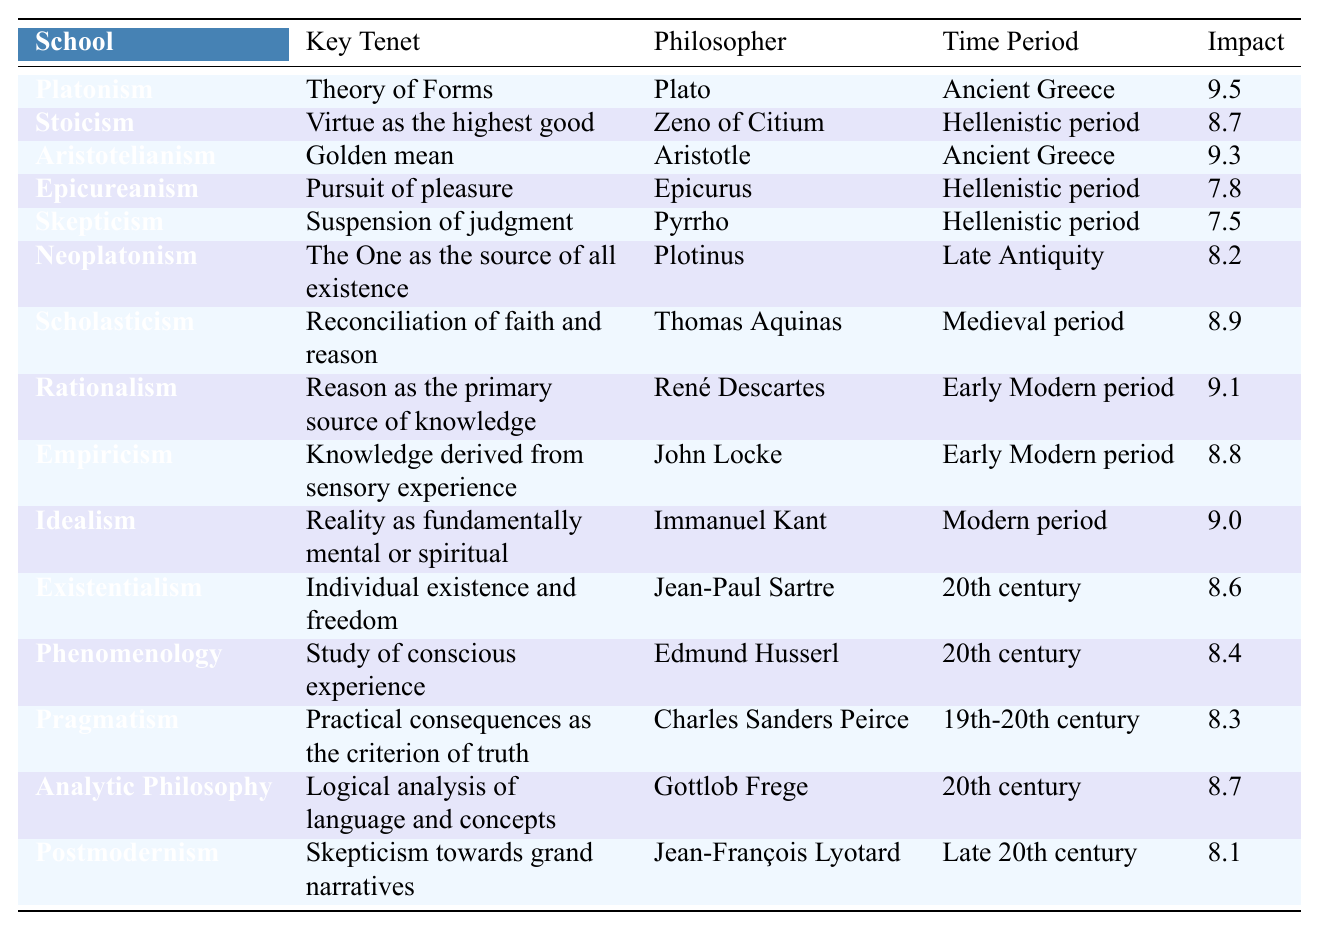What is the key tenet of Stoicism? The table provides a clear entry for Stoicism, showing that its key tenet is "Virtue as the highest good."
Answer: Virtue as the highest good Which philosopher is associated with Aristotelianism? From the table, we observe that Aristotelianism is linked to Aristotle.
Answer: Aristotle How many philosophical schools are associated with the Hellenistic period? The table includes three schools from the Hellenistic period: Stoicism, Epicureanism, and Skepticism, making a total of three.
Answer: 3 What is the impact score of Neoplatonism? Neoplatonism has an impact score of 8.2 as indicated in the table.
Answer: 8.2 Is it true that Rationalism has a higher impact score than Empiricism? The table shows Rationalism with an impact score of 9.1 and Empiricism with 8.8; thus, it is true that Rationalism has a higher score.
Answer: Yes What is the average impact score of the schools from the Ancient Greece? The impact scores for the Ancient Greece schools (Platonism: 9.5, Aristotelianism: 9.3) sum to 18.8. Dividing by 2 gives an average of 9.4.
Answer: 9.4 Which school has the highest impact score, and who is its philosopher? Reviewing the table reveals that Platonism has the highest impact score of 9.5, associated with philosopher Plato.
Answer: Platonism, Plato How does Existentialism's impact score compare to that of Pragmatism? Existentialism has an impact score of 8.6 and Pragmatism has 8.3; therefore, Existentialism has a higher impact score.
Answer: Existentialism is higher Identify the philosopher associated with Idealism and their primary focus. In the table, Idealism is associated with philosopher Immanuel Kant, who focuses on the notion that reality is fundamentally mental or spiritual.
Answer: Immanuel Kant, reality is fundamentally mental or spiritual What impact score do schools from the 20th century average? Adding the impact scores of Existentialism (8.6), Phenomenology (8.4), Analytic Philosophy (8.7) yields a total of 25.7. Dividing by 3 gives an average of approximately 8.57.
Answer: 8.57 